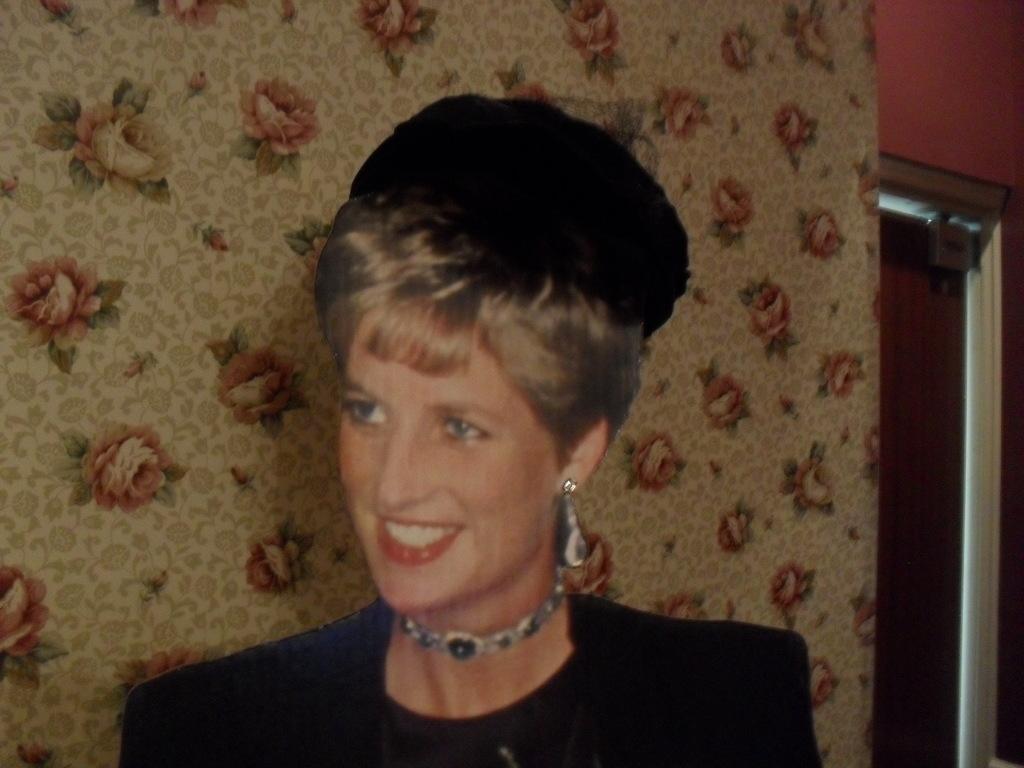How would you summarize this image in a sentence or two? This picture is mainly highlighted with a woman who is holding a beautiful smile on her face. She is wearing a necklace and she is in black dress. Behind to this women and there is a wall with roses and it is artificially made. At the right side of the picture we can see a door and this is a wall in orange colour. 